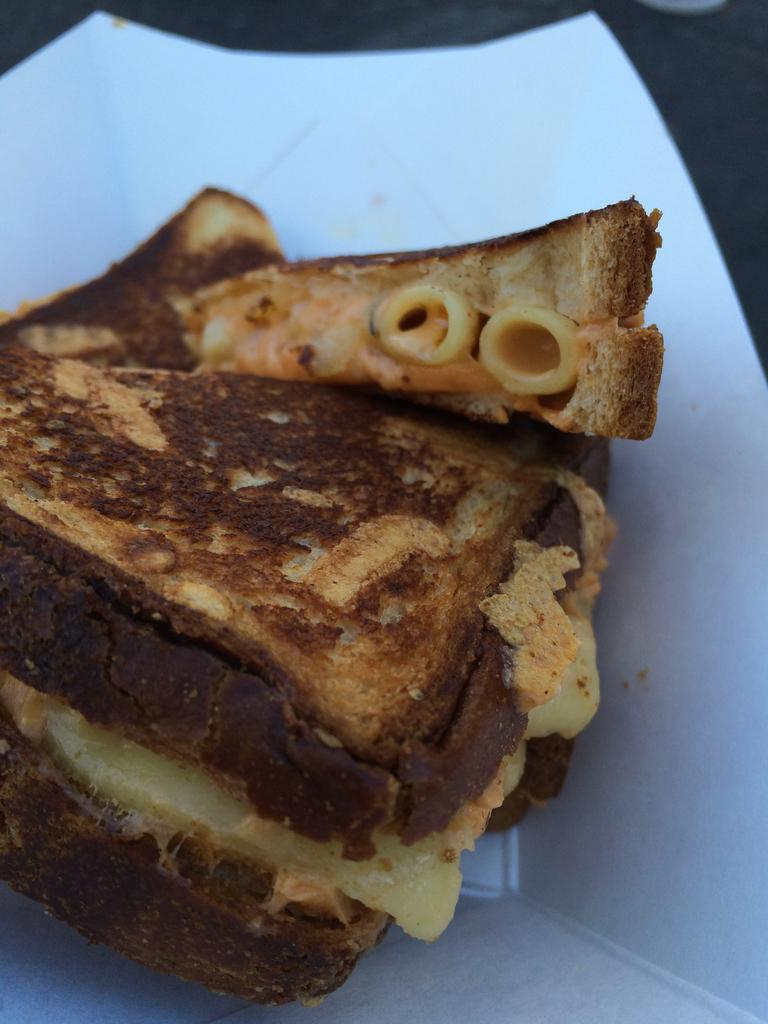What type of food is visible in the image? There is a sandwich in the image. Where is the sandwich placed? The sandwich is on a plate in the image. Can you describe the color of the plate? The color of the plate is not mentioned or clear in the image. What type of treatment is being administered to the wrist in the image? There is no wrist or treatment visible in the image; it only features a sandwich on a plate. 